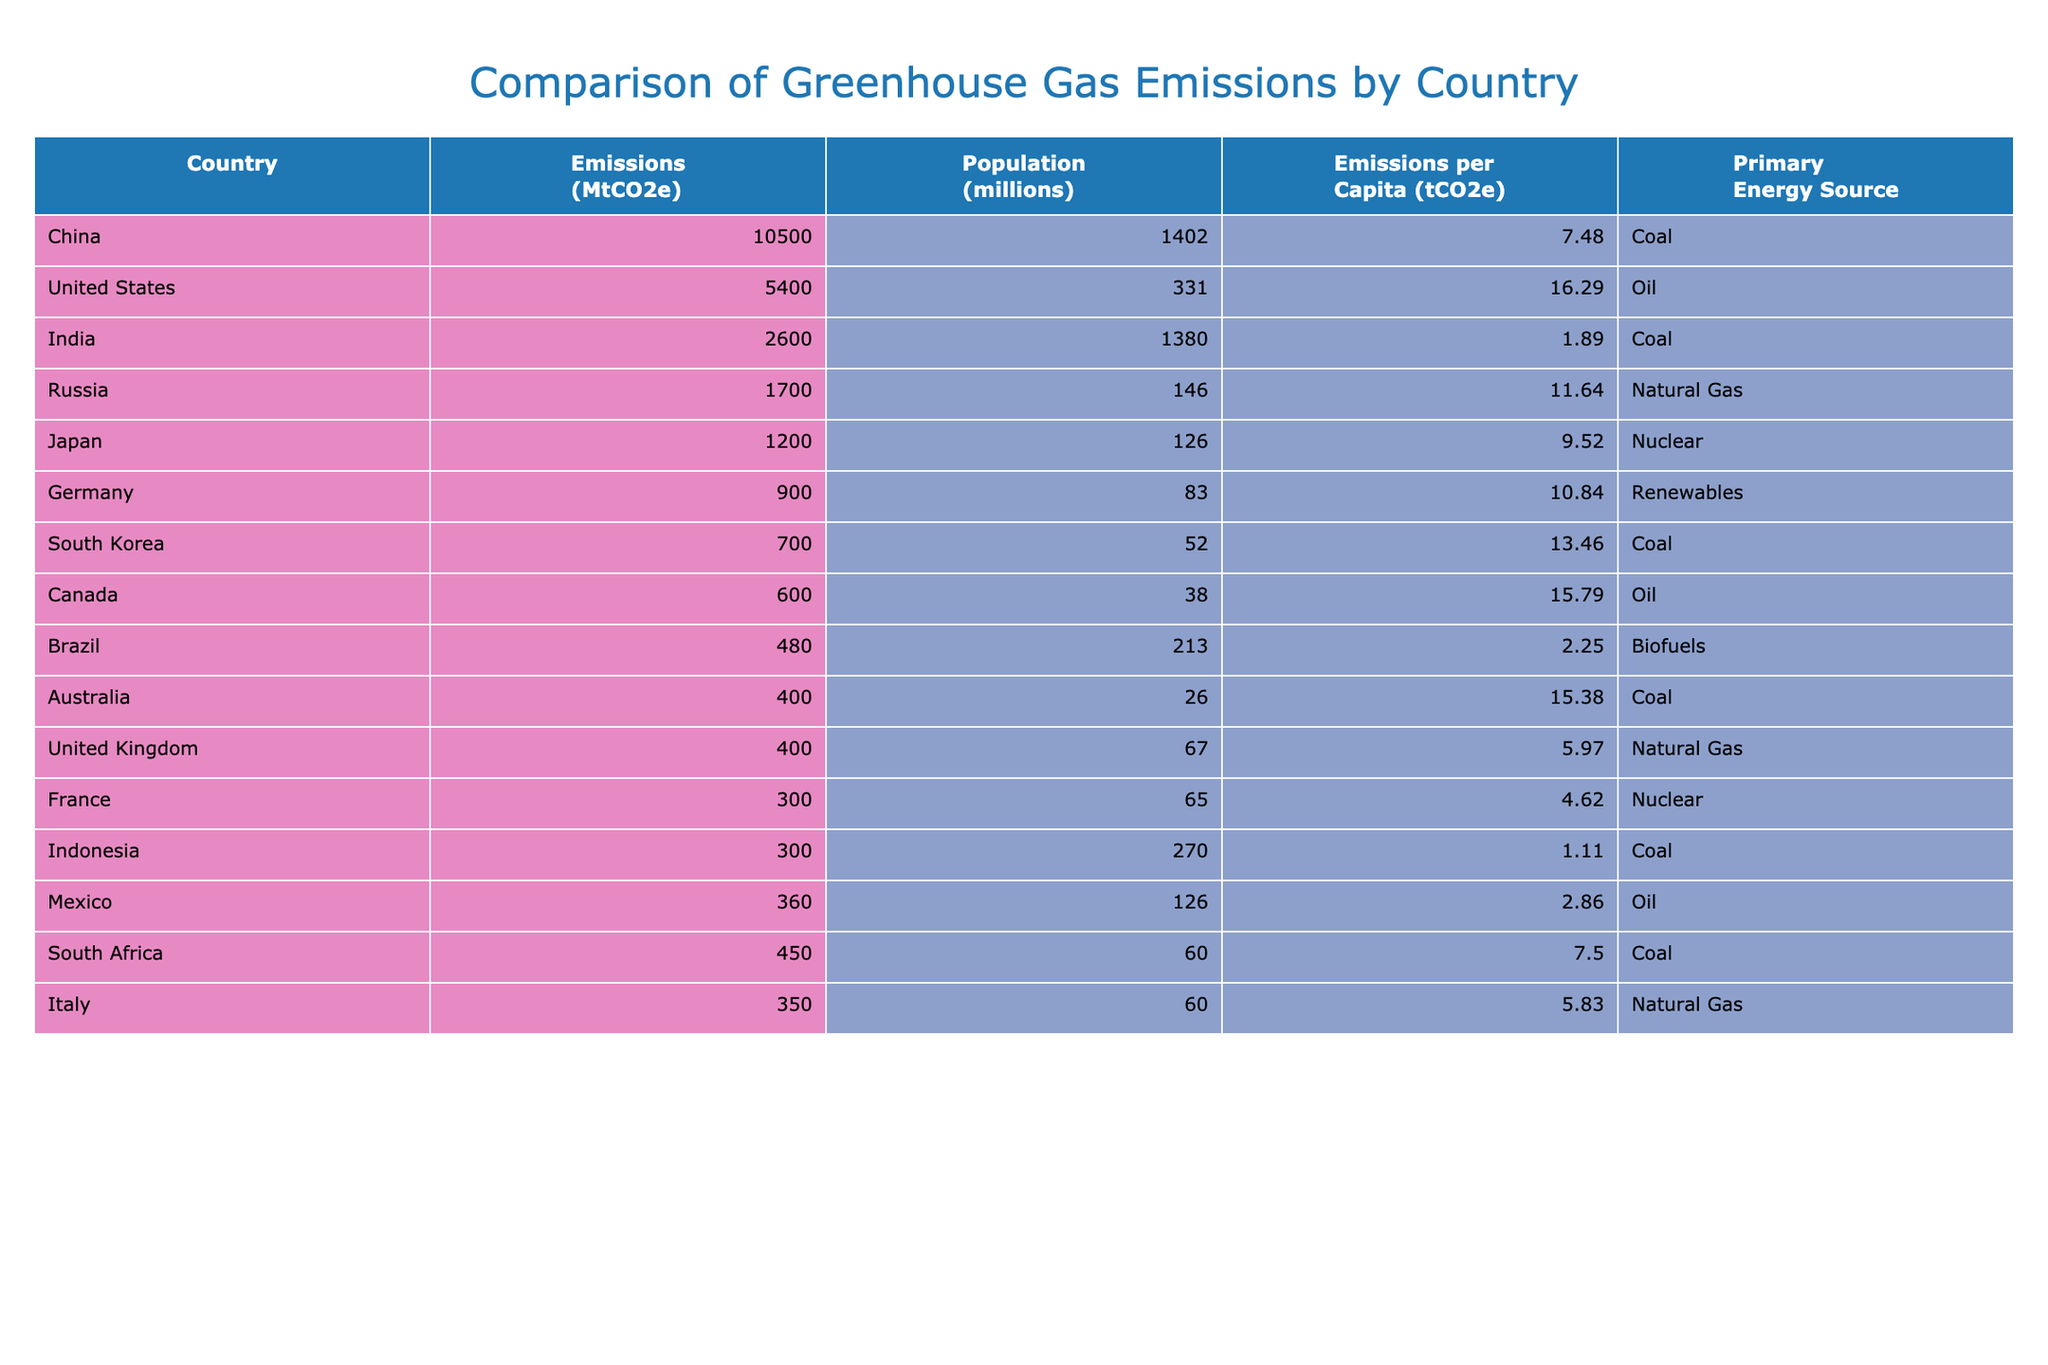What is the country with the highest greenhouse gas emissions? By looking at the emissions column in the table, I can see that China has the highest value at 10,500 MtCO2e.
Answer: China How many countries have emissions classified as 'Very High'? I can filter the emissions category which indicates 'Very High' emissions. The only country in this category is China, hence there is just 1 country.
Answer: 1 Is the United States the only country with more than 5,000 MtCO2e? Checking the emissions values, the United States has 5,400 MtCO2e but is not above 5,000. The only country above that is China. Therefore, it is not the only country; it is actually the second-highest.
Answer: No What is the average emissions per capita for the top three emitters? The top three emitters are China (7.48 tCO2e), the United States (16.29 tCO2e), and India (1.89 tCO2e). To find the average, I sum those values: 7.48 + 16.29 + 1.89 = 25.66 and then divide by 3, which gives approximately 8.55 tCO2e.
Answer: 8.55 Do any countries rely primarily on biofuels as their energy source? By reviewing the primary energy source column, I can see that Brazil is the only country listed that uses biofuels.
Answer: Yes What is the total greenhouse gas emissions in MtCO2e for the countries using Coal as their primary energy source? The countries that use coal are China (10,500 MtCO2e), India (2,600 MtCO2e), South Korea (700 MtCO2e), Australia (400 MtCO2e), and Indonesia (300 MtCO2e). Adding these together gives me a total of 10,500 + 2,600 + 700 + 400 + 300 = 14,500 MtCO2e.
Answer: 14500 Which country has the lowest emissions per capita? Looking at the emissions per capita column, I find that Indonesia has the lowest value at 1.11 tCO2e.
Answer: Indonesia Which country has the same per capita emissions as South Africa? The emissions per capita for South Africa is 7.50 tCO2e. By checking each country’s per capita emissions, I find that China and South Africa have the same per capita emissions rate of 7.50 tCO2e.
Answer: China Do all countries with very high emissions have a primary energy source of coal? The only country in the 'Very High' category is China, which does use coal. Therefore, based on the data, the answer is yes.
Answer: Yes 